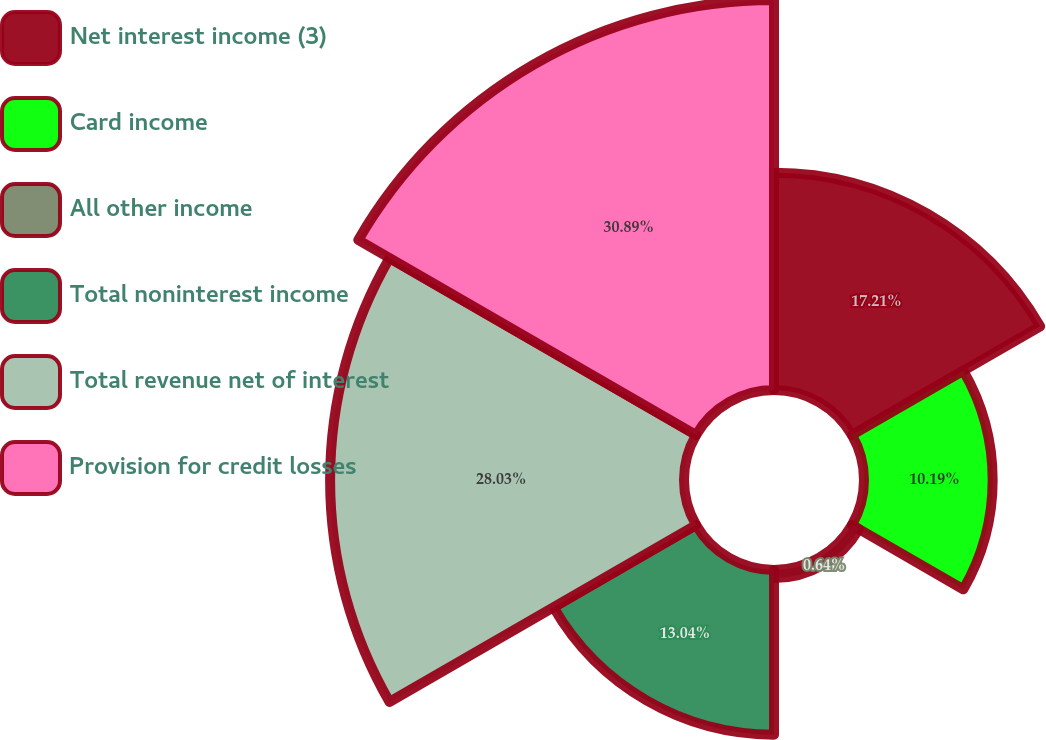Convert chart to OTSL. <chart><loc_0><loc_0><loc_500><loc_500><pie_chart><fcel>Net interest income (3)<fcel>Card income<fcel>All other income<fcel>Total noninterest income<fcel>Total revenue net of interest<fcel>Provision for credit losses<nl><fcel>17.21%<fcel>10.19%<fcel>0.64%<fcel>13.04%<fcel>28.03%<fcel>30.89%<nl></chart> 